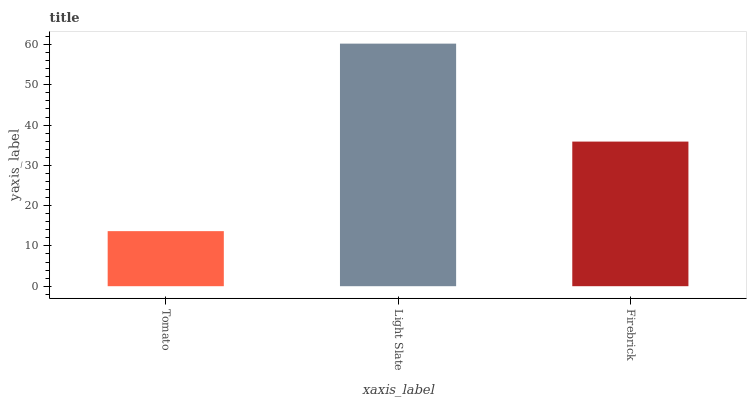Is Tomato the minimum?
Answer yes or no. Yes. Is Light Slate the maximum?
Answer yes or no. Yes. Is Firebrick the minimum?
Answer yes or no. No. Is Firebrick the maximum?
Answer yes or no. No. Is Light Slate greater than Firebrick?
Answer yes or no. Yes. Is Firebrick less than Light Slate?
Answer yes or no. Yes. Is Firebrick greater than Light Slate?
Answer yes or no. No. Is Light Slate less than Firebrick?
Answer yes or no. No. Is Firebrick the high median?
Answer yes or no. Yes. Is Firebrick the low median?
Answer yes or no. Yes. Is Light Slate the high median?
Answer yes or no. No. Is Tomato the low median?
Answer yes or no. No. 